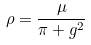Convert formula to latex. <formula><loc_0><loc_0><loc_500><loc_500>\rho = \frac { \mu } { \pi + g ^ { 2 } }</formula> 